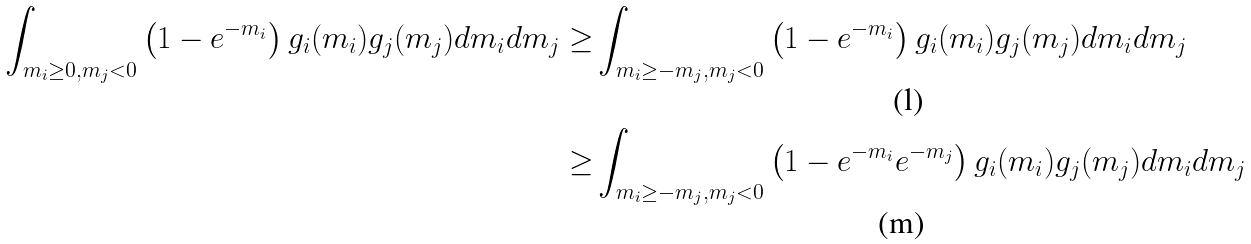<formula> <loc_0><loc_0><loc_500><loc_500>\int _ { m _ { i } \geq 0 , m _ { j } < 0 } \left ( 1 - e ^ { - m _ { i } } \right ) g _ { i } ( m _ { i } ) g _ { j } ( m _ { j } ) d m _ { i } d m _ { j } \geq & \int _ { m _ { i } \geq - m _ { j } , m _ { j } < 0 } \left ( 1 - e ^ { - m _ { i } } \right ) g _ { i } ( m _ { i } ) g _ { j } ( m _ { j } ) d m _ { i } d m _ { j } \\ \geq & \int _ { m _ { i } \geq - m _ { j } , m _ { j } < 0 } \left ( 1 - e ^ { - m _ { i } } e ^ { - m _ { j } } \right ) g _ { i } ( m _ { i } ) g _ { j } ( m _ { j } ) d m _ { i } d m _ { j }</formula> 